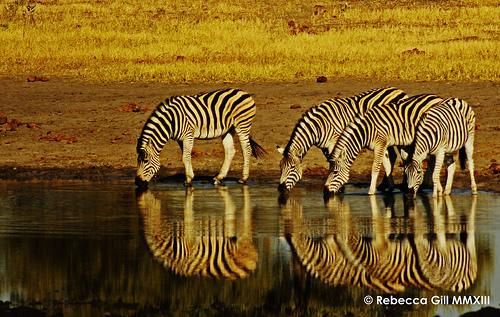Based on the scene depicted in the image, what are the zebras doing, and what can you understand about their condition? The zebras are drinking water, suggesting they are well-adapted to living in the savannah, finding essential resources such as water in their natural environment. What is the sentiment conveyed by the image? The image conveys a serene and natural sentiment of zebras in their wild habitat, peacefully drinking water on the savannah. Identify the type of landscape and the environment predominant in this image. The landscape is a savannah, with brown and yellow grass on the ground, dirt, and some vegetation present around a body of water. Analyze the image and provide a caption that captures the main elements of the scene. "Peaceful Moment: Four Zebras Quenching Their Thirst at the Savannah's Muddy Riverbank" List the different types of ground cover depicted in the photograph. The ground cover in the photograph includes brown and yellow grass, dirt with debris and leaves, and muddy riverside. Count the number of zebras in the picture and describe the physical features of these animals. There are four zebras with black and white stripes, each having four legs, a long tail, and small ears. Describe the water and its surrounding area in the image. The water is calm with slight ripples and has reflections of the trees and zebras in it. The riverbank is muddy and has some grass and debris. Provide a brief description of the primary elements in this image and any actions being taken by the subjects. Four zebras with black and white stripes are at a muddy riverbank, drinking water, while their reflections and some ripples can be seen in the water. What are some notable details about the zebras' interaction with the environment? The zebras are drinking water at the riverside, standing on the muddy ground and grass, and their reflections can be seen in the calm water. What type of vegetation is behind the zebras? Yellow grass and clump of vegetation What additional detail is visible in the water near the zebras? Reflection of zebras and slight ripples What is the shape and color of the zebra's ear? Small and black Are the zebras purple and green in color? This is misleading because zebras are known for their black and white stripes, and there are multiple captions mentioning their black and white stripes. What activity are three of the zebras engaged in? Drinking water Create a caption that includes information about the zebras, the water, and the terrain. Four zebras with black and white stripes drinking water at a muddy riverbank with yellow grass and dirt ground List the colors of the zebra stripes. Black and white Describe the terrain where the zebras are found in the image. Muddy water bank with yellow grass and dirt ground What is visible in the water in addition to the slight ripples? Reflections of zebras and trees Select a feature of the zebra's anatomy mentioned in the captions. A) Long neck, B) Black nose, C) Small ear, D) Big eyes C) Small ear What is the state of the water in the image? Calm with slight ripples What is on the ground, besides dirt and debris? Bodily waste of an animal What type of image is being described, based on the presence of animals, water, and vegetation? African savannah with zebras at a waterhole What is the color of the zebra hoof? Black Is there a city skyline visible in the background? This is misleading because no caption mentions a city skyline or any kind of urban environment. The scene is described as a savannah with zebras, yellow grass, dirt, and water. What does the shoreline where zebras are drinking look like? Muddy with vegetation and dirt What is the color of the earth in the image? Brown The grass in the image is described as both "yellow and short" and "brown." Which description is more accurate? Yellow and short Is there a lion next to the zebras? This is misleading because there is no mention of a lion in any of the captions. All captions focus on zebras, their stripes, the water, and the surroundings. Is the water raging with strong currents? This instruction contradicts many captions that describe the water as calm, with slight ripples, and having smooth undisturbed water. Are there only two zebras in the image? This is misleading as several captions mention four zebras, and others talk about three zebras drinking water. None of the captions mention just two zebras. What is written on the professional stamp on the image? Rebecca Gill Caption 2013 Is the grass in the background tall and green? This instruction is misleading as the grass is described as yellow, short, and brown in various captions. No mention of green or tall grass is made. How many zebras are there in the image? Four 